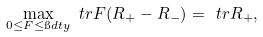Convert formula to latex. <formula><loc_0><loc_0><loc_500><loc_500>\max _ { 0 \leq F \leq \i d t y } \ t r { F ( R _ { + } - R _ { - } ) } = \ t r { R _ { + } } ,</formula> 